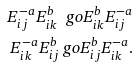Convert formula to latex. <formula><loc_0><loc_0><loc_500><loc_500>E _ { i j } ^ { - a } E _ { i k } ^ { b } \ g o E _ { i k } ^ { b } E _ { i j } ^ { - a } \\ E _ { i k } ^ { - a } E _ { i j } ^ { b } \ g o E _ { i j } ^ { b } E _ { i k } ^ { - a } .</formula> 